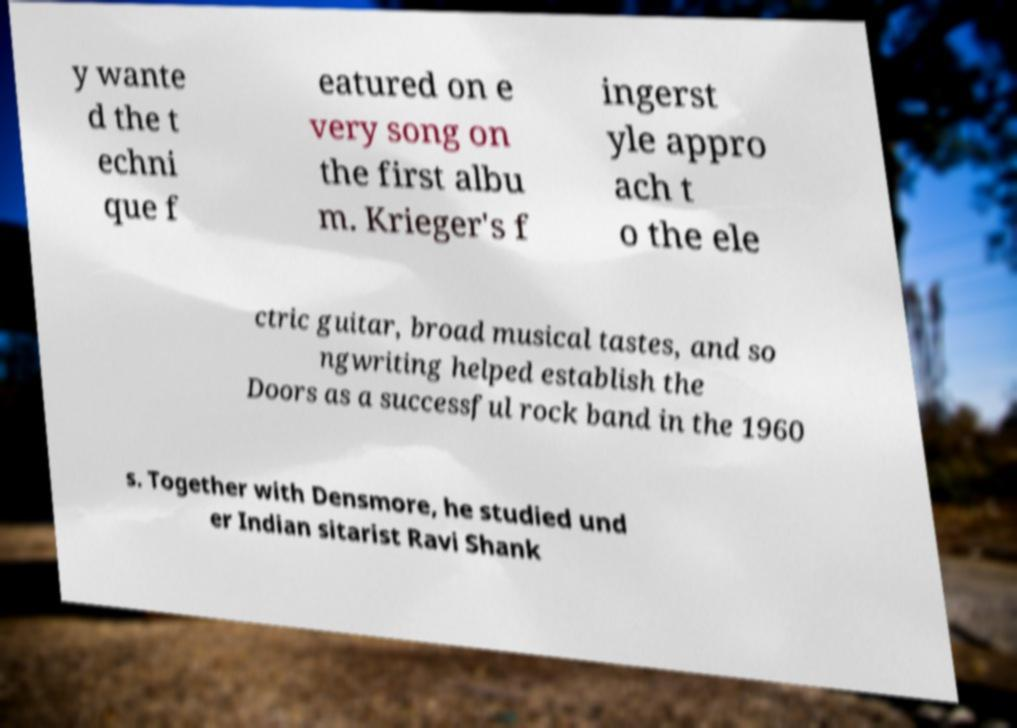I need the written content from this picture converted into text. Can you do that? y wante d the t echni que f eatured on e very song on the first albu m. Krieger's f ingerst yle appro ach t o the ele ctric guitar, broad musical tastes, and so ngwriting helped establish the Doors as a successful rock band in the 1960 s. Together with Densmore, he studied und er Indian sitarist Ravi Shank 